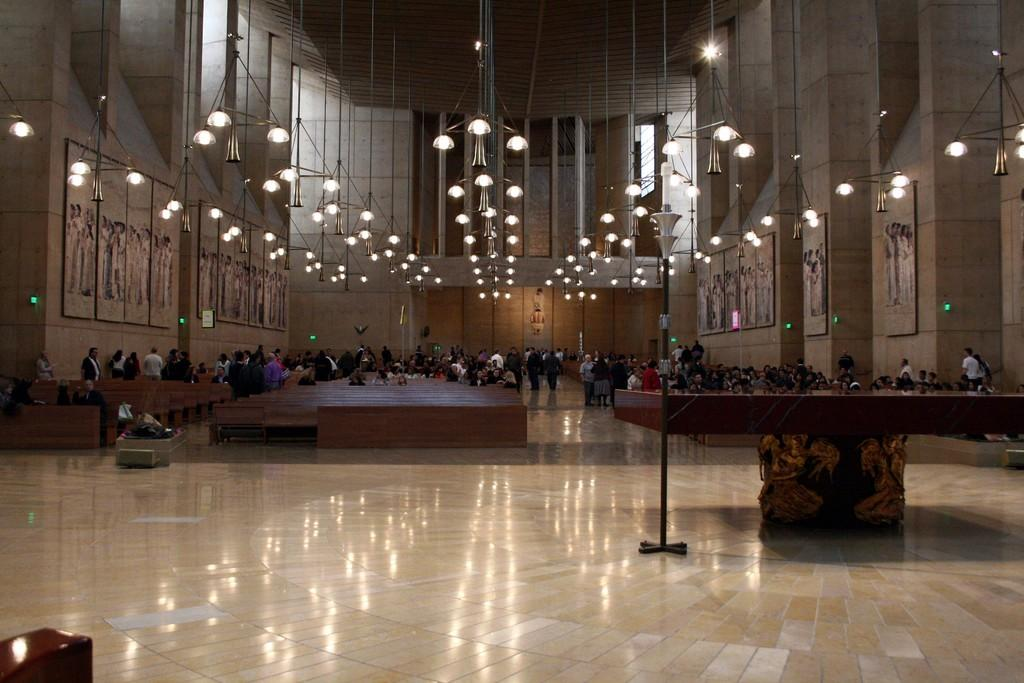How many people are in the image? There are persons in the image, but the exact number is not specified. What type of lighting is present in the image? There are lights in the image. What type of furniture can be seen in the image? There are tables and benches in the image. What is visible on the floor in the image? The floor is visible in the image. What type of structure is present in the image? There is a wall in the image. Can you hear the quiet hands clapping in the image? There is no mention of hands clapping or any sound in the image, so it is not possible to answer this question. 